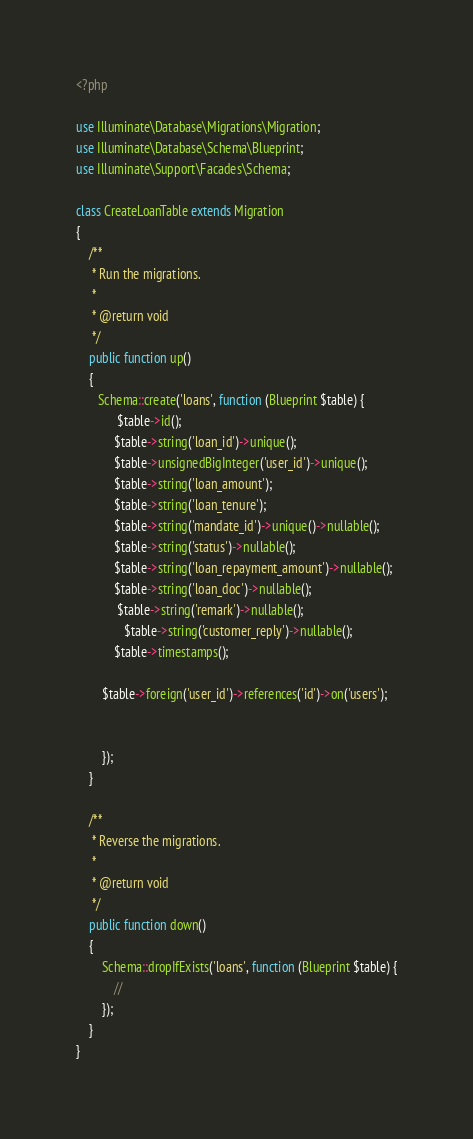<code> <loc_0><loc_0><loc_500><loc_500><_PHP_><?php

use Illuminate\Database\Migrations\Migration;
use Illuminate\Database\Schema\Blueprint;
use Illuminate\Support\Facades\Schema;

class CreateLoanTable extends Migration
{
    /**
     * Run the migrations.
     *
     * @return void
     */
    public function up()
    {
       Schema::create('loans', function (Blueprint $table) {
             $table->id();
            $table->string('loan_id')->unique();
            $table->unsignedBigInteger('user_id')->unique();
            $table->string('loan_amount');
            $table->string('loan_tenure');
            $table->string('mandate_id')->unique()->nullable();
            $table->string('status')->nullable();
            $table->string('loan_repayment_amount')->nullable();
            $table->string('loan_doc')->nullable();
             $table->string('remark')->nullable();
               $table->string('customer_reply')->nullable();
            $table->timestamps();

        $table->foreign('user_id')->references('id')->on('users');


        });
    }

    /**
     * Reverse the migrations.
     *
     * @return void
     */
    public function down()
    {
        Schema::dropIfExists('loans', function (Blueprint $table) {
            //
        });
    }
}
</code> 